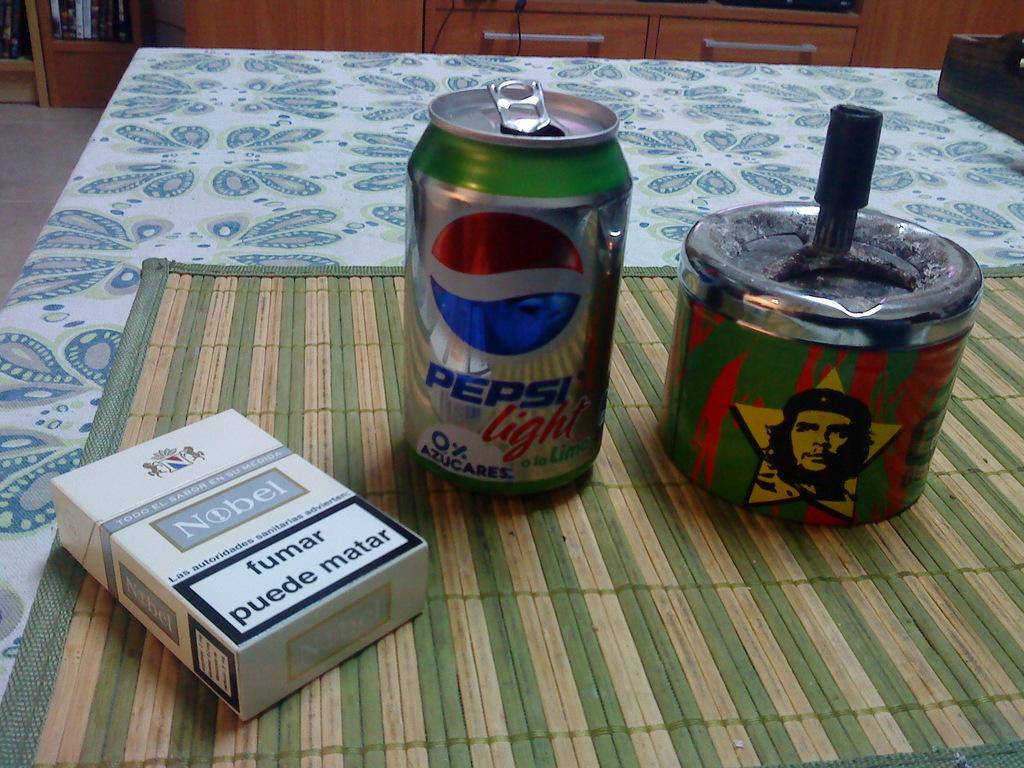Describe this image in one or two sentences. In this image there is a table and we can see a mat, tens and a carton placed on the table. In the background we can see a cupboard and there are things placed in the cupboard. 